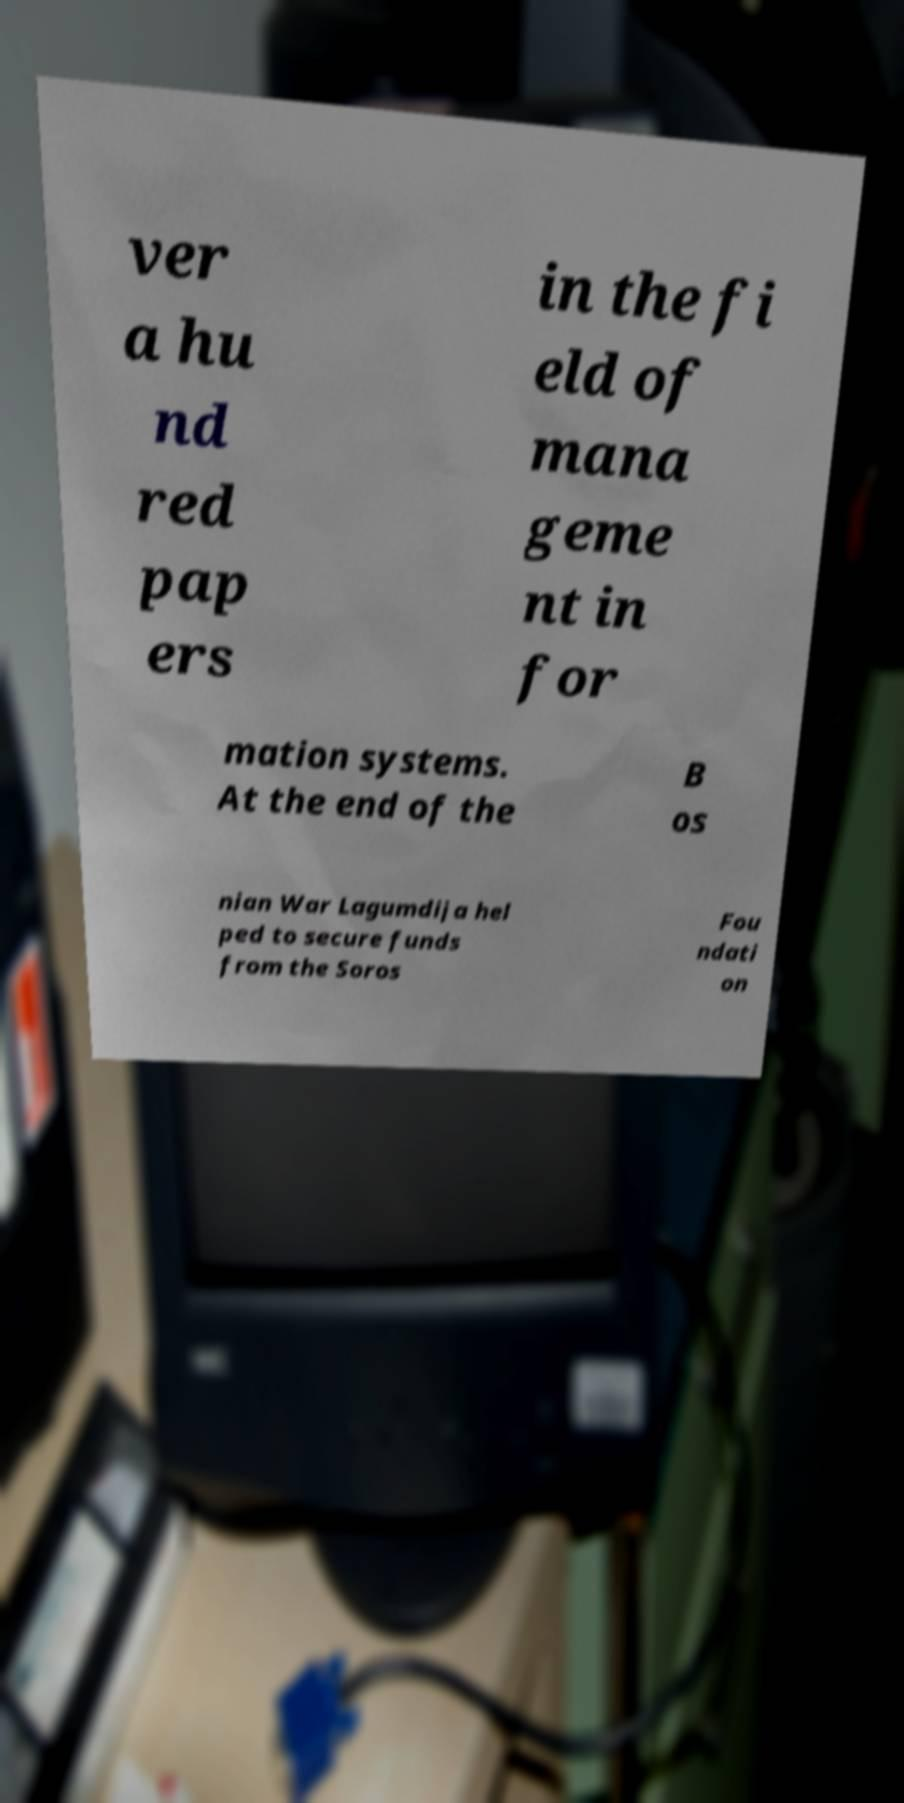Could you extract and type out the text from this image? ver a hu nd red pap ers in the fi eld of mana geme nt in for mation systems. At the end of the B os nian War Lagumdija hel ped to secure funds from the Soros Fou ndati on 